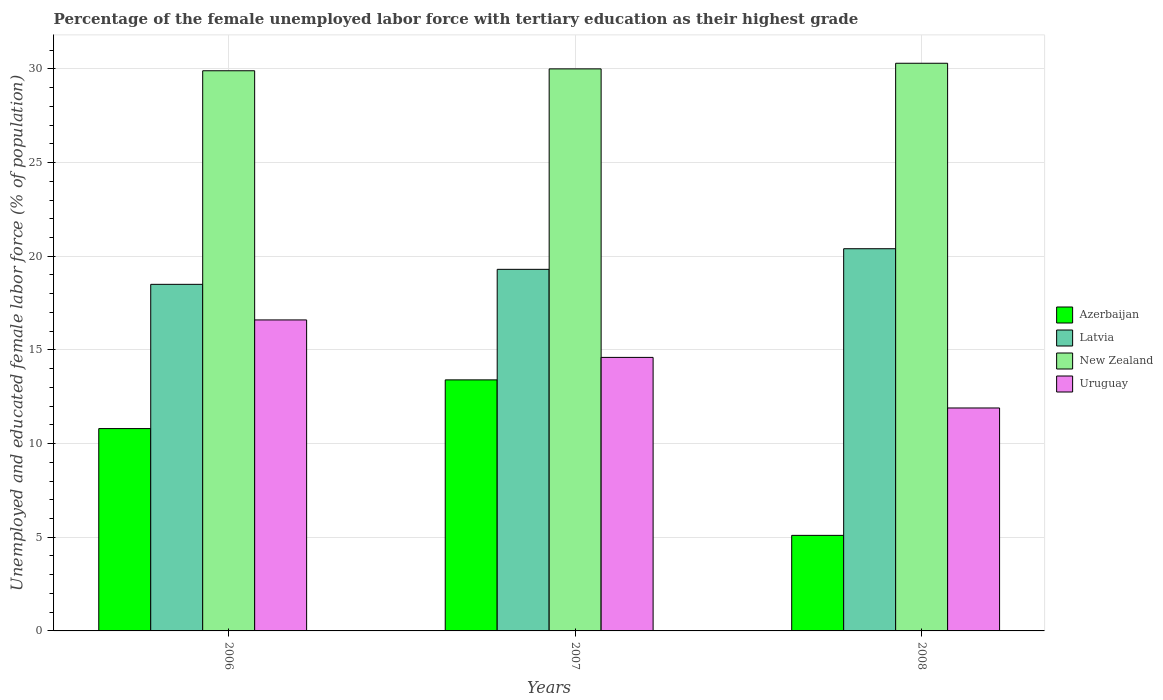How many groups of bars are there?
Provide a succinct answer. 3. What is the label of the 3rd group of bars from the left?
Your response must be concise. 2008. In how many cases, is the number of bars for a given year not equal to the number of legend labels?
Provide a short and direct response. 0. What is the percentage of the unemployed female labor force with tertiary education in Azerbaijan in 2008?
Offer a terse response. 5.1. Across all years, what is the maximum percentage of the unemployed female labor force with tertiary education in Azerbaijan?
Make the answer very short. 13.4. Across all years, what is the minimum percentage of the unemployed female labor force with tertiary education in New Zealand?
Give a very brief answer. 29.9. In which year was the percentage of the unemployed female labor force with tertiary education in Azerbaijan maximum?
Ensure brevity in your answer.  2007. What is the total percentage of the unemployed female labor force with tertiary education in Latvia in the graph?
Keep it short and to the point. 58.2. What is the difference between the percentage of the unemployed female labor force with tertiary education in Latvia in 2007 and that in 2008?
Ensure brevity in your answer.  -1.1. What is the difference between the percentage of the unemployed female labor force with tertiary education in Azerbaijan in 2008 and the percentage of the unemployed female labor force with tertiary education in Uruguay in 2006?
Make the answer very short. -11.5. What is the average percentage of the unemployed female labor force with tertiary education in Uruguay per year?
Your answer should be compact. 14.37. In the year 2008, what is the difference between the percentage of the unemployed female labor force with tertiary education in Uruguay and percentage of the unemployed female labor force with tertiary education in New Zealand?
Provide a succinct answer. -18.4. In how many years, is the percentage of the unemployed female labor force with tertiary education in Azerbaijan greater than 6 %?
Offer a very short reply. 2. What is the ratio of the percentage of the unemployed female labor force with tertiary education in Latvia in 2007 to that in 2008?
Provide a succinct answer. 0.95. Is the percentage of the unemployed female labor force with tertiary education in Azerbaijan in 2007 less than that in 2008?
Offer a very short reply. No. Is the difference between the percentage of the unemployed female labor force with tertiary education in Uruguay in 2006 and 2007 greater than the difference between the percentage of the unemployed female labor force with tertiary education in New Zealand in 2006 and 2007?
Provide a succinct answer. Yes. What is the difference between the highest and the second highest percentage of the unemployed female labor force with tertiary education in Uruguay?
Your response must be concise. 2. What is the difference between the highest and the lowest percentage of the unemployed female labor force with tertiary education in New Zealand?
Give a very brief answer. 0.4. Is the sum of the percentage of the unemployed female labor force with tertiary education in Azerbaijan in 2007 and 2008 greater than the maximum percentage of the unemployed female labor force with tertiary education in Uruguay across all years?
Offer a terse response. Yes. What does the 3rd bar from the left in 2006 represents?
Provide a succinct answer. New Zealand. What does the 3rd bar from the right in 2007 represents?
Offer a very short reply. Latvia. Is it the case that in every year, the sum of the percentage of the unemployed female labor force with tertiary education in New Zealand and percentage of the unemployed female labor force with tertiary education in Latvia is greater than the percentage of the unemployed female labor force with tertiary education in Uruguay?
Your answer should be very brief. Yes. How many bars are there?
Make the answer very short. 12. How many years are there in the graph?
Provide a short and direct response. 3. How many legend labels are there?
Make the answer very short. 4. How are the legend labels stacked?
Your answer should be very brief. Vertical. What is the title of the graph?
Your answer should be compact. Percentage of the female unemployed labor force with tertiary education as their highest grade. What is the label or title of the X-axis?
Your answer should be very brief. Years. What is the label or title of the Y-axis?
Keep it short and to the point. Unemployed and educated female labor force (% of population). What is the Unemployed and educated female labor force (% of population) of Azerbaijan in 2006?
Offer a terse response. 10.8. What is the Unemployed and educated female labor force (% of population) in New Zealand in 2006?
Your answer should be compact. 29.9. What is the Unemployed and educated female labor force (% of population) in Uruguay in 2006?
Provide a short and direct response. 16.6. What is the Unemployed and educated female labor force (% of population) in Azerbaijan in 2007?
Ensure brevity in your answer.  13.4. What is the Unemployed and educated female labor force (% of population) in Latvia in 2007?
Provide a short and direct response. 19.3. What is the Unemployed and educated female labor force (% of population) in Uruguay in 2007?
Your response must be concise. 14.6. What is the Unemployed and educated female labor force (% of population) of Azerbaijan in 2008?
Offer a very short reply. 5.1. What is the Unemployed and educated female labor force (% of population) of Latvia in 2008?
Your response must be concise. 20.4. What is the Unemployed and educated female labor force (% of population) of New Zealand in 2008?
Provide a short and direct response. 30.3. What is the Unemployed and educated female labor force (% of population) in Uruguay in 2008?
Make the answer very short. 11.9. Across all years, what is the maximum Unemployed and educated female labor force (% of population) in Azerbaijan?
Ensure brevity in your answer.  13.4. Across all years, what is the maximum Unemployed and educated female labor force (% of population) of Latvia?
Keep it short and to the point. 20.4. Across all years, what is the maximum Unemployed and educated female labor force (% of population) of New Zealand?
Offer a terse response. 30.3. Across all years, what is the maximum Unemployed and educated female labor force (% of population) in Uruguay?
Your answer should be very brief. 16.6. Across all years, what is the minimum Unemployed and educated female labor force (% of population) of Azerbaijan?
Your answer should be compact. 5.1. Across all years, what is the minimum Unemployed and educated female labor force (% of population) of New Zealand?
Offer a terse response. 29.9. Across all years, what is the minimum Unemployed and educated female labor force (% of population) in Uruguay?
Your answer should be compact. 11.9. What is the total Unemployed and educated female labor force (% of population) of Azerbaijan in the graph?
Keep it short and to the point. 29.3. What is the total Unemployed and educated female labor force (% of population) of Latvia in the graph?
Offer a very short reply. 58.2. What is the total Unemployed and educated female labor force (% of population) of New Zealand in the graph?
Give a very brief answer. 90.2. What is the total Unemployed and educated female labor force (% of population) of Uruguay in the graph?
Offer a very short reply. 43.1. What is the difference between the Unemployed and educated female labor force (% of population) of Latvia in 2006 and that in 2007?
Provide a short and direct response. -0.8. What is the difference between the Unemployed and educated female labor force (% of population) in Uruguay in 2006 and that in 2007?
Provide a short and direct response. 2. What is the difference between the Unemployed and educated female labor force (% of population) in Azerbaijan in 2006 and that in 2008?
Give a very brief answer. 5.7. What is the difference between the Unemployed and educated female labor force (% of population) in Latvia in 2006 and that in 2008?
Keep it short and to the point. -1.9. What is the difference between the Unemployed and educated female labor force (% of population) in New Zealand in 2006 and that in 2008?
Offer a terse response. -0.4. What is the difference between the Unemployed and educated female labor force (% of population) in Uruguay in 2006 and that in 2008?
Offer a terse response. 4.7. What is the difference between the Unemployed and educated female labor force (% of population) in Azerbaijan in 2007 and that in 2008?
Provide a succinct answer. 8.3. What is the difference between the Unemployed and educated female labor force (% of population) in Latvia in 2007 and that in 2008?
Your response must be concise. -1.1. What is the difference between the Unemployed and educated female labor force (% of population) in New Zealand in 2007 and that in 2008?
Your answer should be very brief. -0.3. What is the difference between the Unemployed and educated female labor force (% of population) of Azerbaijan in 2006 and the Unemployed and educated female labor force (% of population) of Latvia in 2007?
Provide a succinct answer. -8.5. What is the difference between the Unemployed and educated female labor force (% of population) of Azerbaijan in 2006 and the Unemployed and educated female labor force (% of population) of New Zealand in 2007?
Ensure brevity in your answer.  -19.2. What is the difference between the Unemployed and educated female labor force (% of population) of Azerbaijan in 2006 and the Unemployed and educated female labor force (% of population) of Uruguay in 2007?
Your answer should be very brief. -3.8. What is the difference between the Unemployed and educated female labor force (% of population) in Latvia in 2006 and the Unemployed and educated female labor force (% of population) in New Zealand in 2007?
Offer a terse response. -11.5. What is the difference between the Unemployed and educated female labor force (% of population) of New Zealand in 2006 and the Unemployed and educated female labor force (% of population) of Uruguay in 2007?
Offer a very short reply. 15.3. What is the difference between the Unemployed and educated female labor force (% of population) in Azerbaijan in 2006 and the Unemployed and educated female labor force (% of population) in New Zealand in 2008?
Keep it short and to the point. -19.5. What is the difference between the Unemployed and educated female labor force (% of population) of Latvia in 2006 and the Unemployed and educated female labor force (% of population) of New Zealand in 2008?
Keep it short and to the point. -11.8. What is the difference between the Unemployed and educated female labor force (% of population) of Latvia in 2006 and the Unemployed and educated female labor force (% of population) of Uruguay in 2008?
Give a very brief answer. 6.6. What is the difference between the Unemployed and educated female labor force (% of population) in New Zealand in 2006 and the Unemployed and educated female labor force (% of population) in Uruguay in 2008?
Offer a very short reply. 18. What is the difference between the Unemployed and educated female labor force (% of population) of Azerbaijan in 2007 and the Unemployed and educated female labor force (% of population) of Latvia in 2008?
Your response must be concise. -7. What is the difference between the Unemployed and educated female labor force (% of population) of Azerbaijan in 2007 and the Unemployed and educated female labor force (% of population) of New Zealand in 2008?
Give a very brief answer. -16.9. What is the difference between the Unemployed and educated female labor force (% of population) in Latvia in 2007 and the Unemployed and educated female labor force (% of population) in Uruguay in 2008?
Make the answer very short. 7.4. What is the difference between the Unemployed and educated female labor force (% of population) of New Zealand in 2007 and the Unemployed and educated female labor force (% of population) of Uruguay in 2008?
Give a very brief answer. 18.1. What is the average Unemployed and educated female labor force (% of population) in Azerbaijan per year?
Make the answer very short. 9.77. What is the average Unemployed and educated female labor force (% of population) in Latvia per year?
Make the answer very short. 19.4. What is the average Unemployed and educated female labor force (% of population) of New Zealand per year?
Ensure brevity in your answer.  30.07. What is the average Unemployed and educated female labor force (% of population) of Uruguay per year?
Your response must be concise. 14.37. In the year 2006, what is the difference between the Unemployed and educated female labor force (% of population) of Azerbaijan and Unemployed and educated female labor force (% of population) of New Zealand?
Provide a short and direct response. -19.1. In the year 2006, what is the difference between the Unemployed and educated female labor force (% of population) of New Zealand and Unemployed and educated female labor force (% of population) of Uruguay?
Your answer should be very brief. 13.3. In the year 2007, what is the difference between the Unemployed and educated female labor force (% of population) of Azerbaijan and Unemployed and educated female labor force (% of population) of Latvia?
Ensure brevity in your answer.  -5.9. In the year 2007, what is the difference between the Unemployed and educated female labor force (% of population) in Azerbaijan and Unemployed and educated female labor force (% of population) in New Zealand?
Give a very brief answer. -16.6. In the year 2007, what is the difference between the Unemployed and educated female labor force (% of population) of Latvia and Unemployed and educated female labor force (% of population) of New Zealand?
Give a very brief answer. -10.7. In the year 2007, what is the difference between the Unemployed and educated female labor force (% of population) of New Zealand and Unemployed and educated female labor force (% of population) of Uruguay?
Provide a succinct answer. 15.4. In the year 2008, what is the difference between the Unemployed and educated female labor force (% of population) of Azerbaijan and Unemployed and educated female labor force (% of population) of Latvia?
Provide a short and direct response. -15.3. In the year 2008, what is the difference between the Unemployed and educated female labor force (% of population) in Azerbaijan and Unemployed and educated female labor force (% of population) in New Zealand?
Offer a terse response. -25.2. In the year 2008, what is the difference between the Unemployed and educated female labor force (% of population) in Azerbaijan and Unemployed and educated female labor force (% of population) in Uruguay?
Give a very brief answer. -6.8. In the year 2008, what is the difference between the Unemployed and educated female labor force (% of population) in Latvia and Unemployed and educated female labor force (% of population) in New Zealand?
Your response must be concise. -9.9. In the year 2008, what is the difference between the Unemployed and educated female labor force (% of population) in New Zealand and Unemployed and educated female labor force (% of population) in Uruguay?
Keep it short and to the point. 18.4. What is the ratio of the Unemployed and educated female labor force (% of population) of Azerbaijan in 2006 to that in 2007?
Your response must be concise. 0.81. What is the ratio of the Unemployed and educated female labor force (% of population) in Latvia in 2006 to that in 2007?
Provide a short and direct response. 0.96. What is the ratio of the Unemployed and educated female labor force (% of population) of Uruguay in 2006 to that in 2007?
Provide a succinct answer. 1.14. What is the ratio of the Unemployed and educated female labor force (% of population) of Azerbaijan in 2006 to that in 2008?
Give a very brief answer. 2.12. What is the ratio of the Unemployed and educated female labor force (% of population) of Latvia in 2006 to that in 2008?
Ensure brevity in your answer.  0.91. What is the ratio of the Unemployed and educated female labor force (% of population) in New Zealand in 2006 to that in 2008?
Make the answer very short. 0.99. What is the ratio of the Unemployed and educated female labor force (% of population) in Uruguay in 2006 to that in 2008?
Your answer should be very brief. 1.4. What is the ratio of the Unemployed and educated female labor force (% of population) of Azerbaijan in 2007 to that in 2008?
Provide a short and direct response. 2.63. What is the ratio of the Unemployed and educated female labor force (% of population) in Latvia in 2007 to that in 2008?
Offer a terse response. 0.95. What is the ratio of the Unemployed and educated female labor force (% of population) in Uruguay in 2007 to that in 2008?
Give a very brief answer. 1.23. What is the difference between the highest and the second highest Unemployed and educated female labor force (% of population) of Latvia?
Your response must be concise. 1.1. What is the difference between the highest and the second highest Unemployed and educated female labor force (% of population) in New Zealand?
Make the answer very short. 0.3. What is the difference between the highest and the second highest Unemployed and educated female labor force (% of population) of Uruguay?
Provide a succinct answer. 2. What is the difference between the highest and the lowest Unemployed and educated female labor force (% of population) of New Zealand?
Your answer should be very brief. 0.4. 